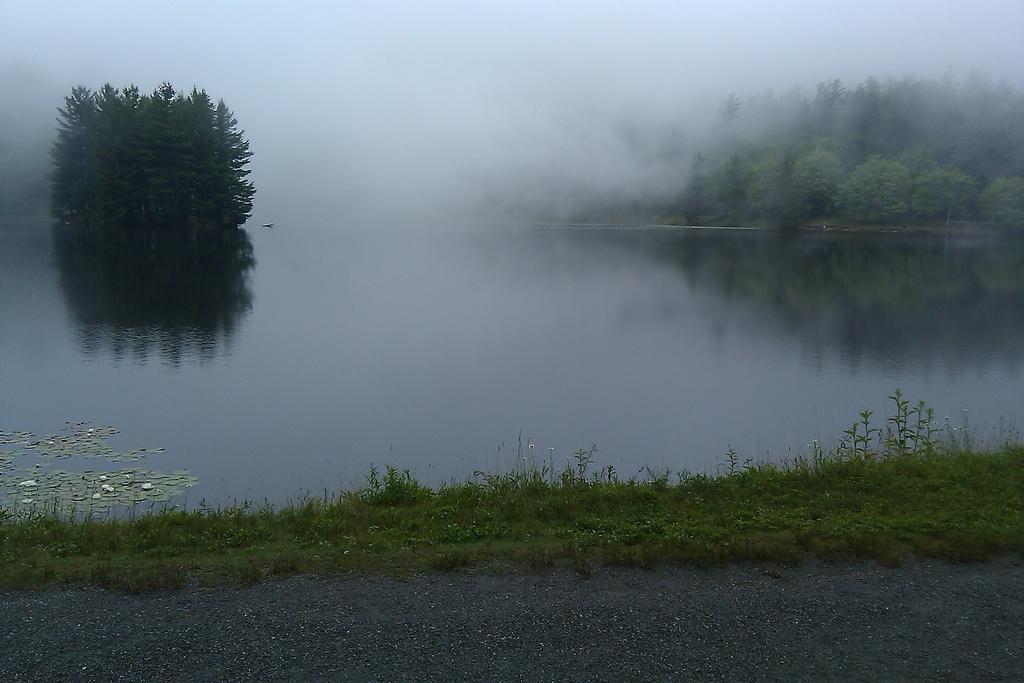Could you give a brief overview of what you see in this image? This image is clicked outside. There is water in this image. There are trees in this image. There is snow in this image. 